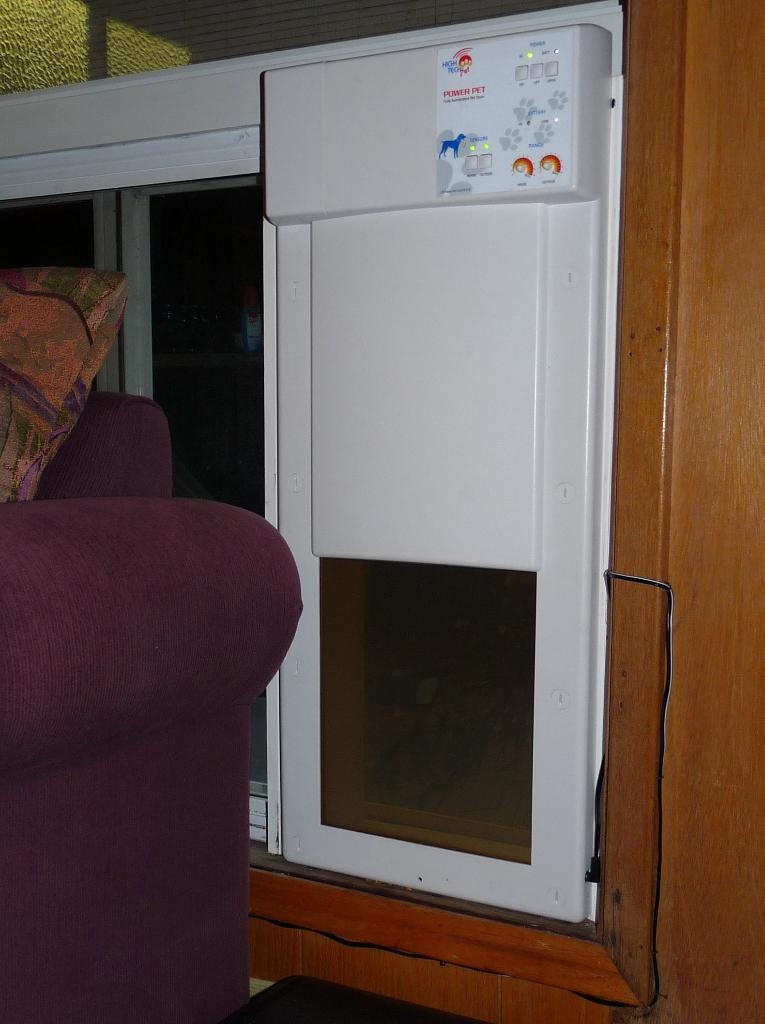<image>
Relay a brief, clear account of the picture shown. A Power Pet pet door is installed in a wooden door. 